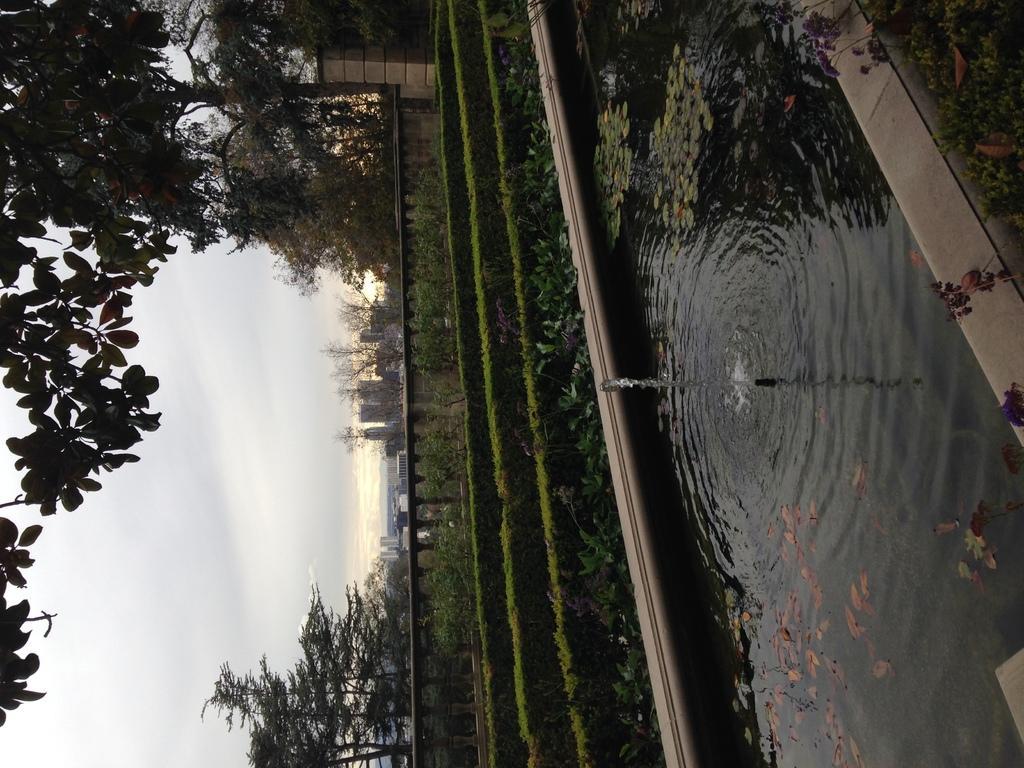Could you give a brief overview of what you see in this image? In this image, we can see water, there are some plants and trees, we can see the wall and there is a pillar, we can see the buildings, we can see the sky. 